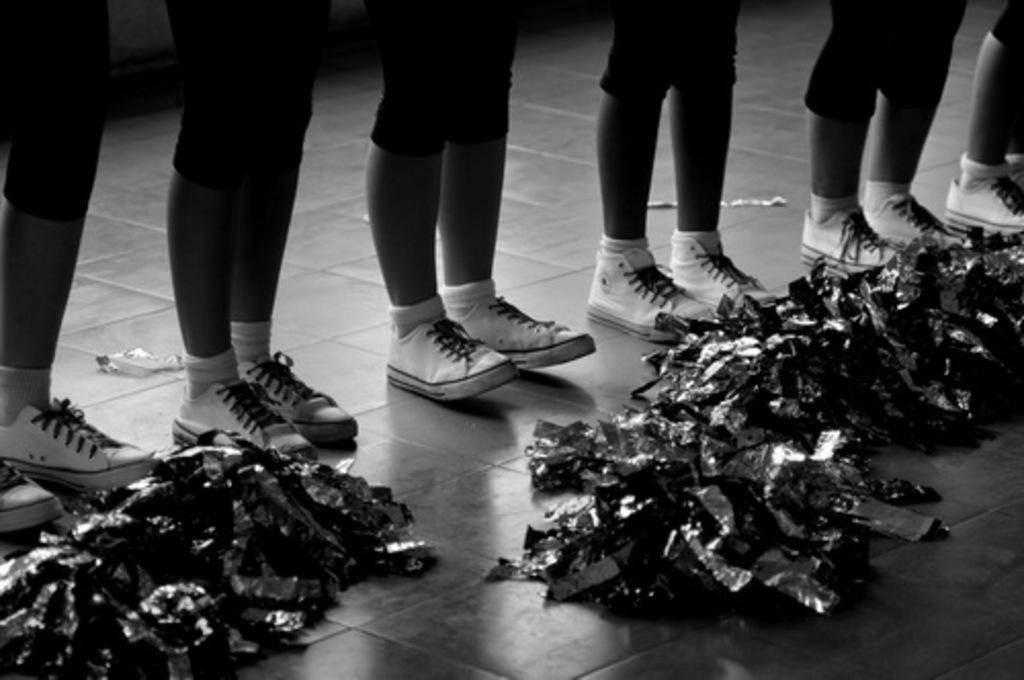What can be seen at the bottom of the people's bodies in the image? There are legs of many people visible in the image. What type of footwear and clothing are the people wearing? The people are wearing shoes and socks. What is present on the ground in the image? There are items on the ground in the image. What is the color scheme of the image? The image is black and white. What type of nut is being burned in the image? There is no nut or burning activity present in the image. What type of brass instrument can be seen in the image? There is no brass instrument present in the image. 